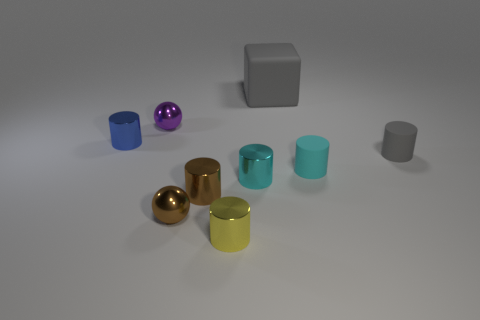Subtract all small yellow cylinders. How many cylinders are left? 5 Subtract all purple spheres. How many cyan cylinders are left? 2 Subtract all gray cylinders. How many cylinders are left? 5 Add 1 large yellow metal balls. How many objects exist? 10 Subtract 3 cylinders. How many cylinders are left? 3 Subtract all spheres. How many objects are left? 7 Subtract 0 cyan spheres. How many objects are left? 9 Subtract all purple cylinders. Subtract all green blocks. How many cylinders are left? 6 Subtract all gray matte balls. Subtract all blue metal objects. How many objects are left? 8 Add 2 blue metallic cylinders. How many blue metallic cylinders are left? 3 